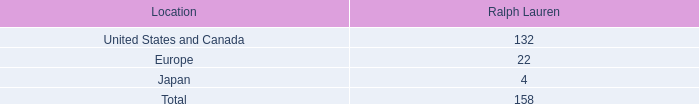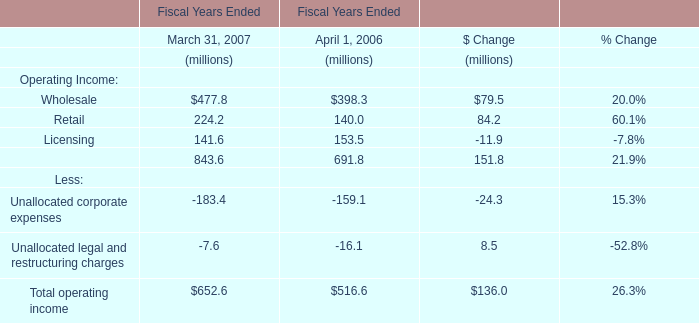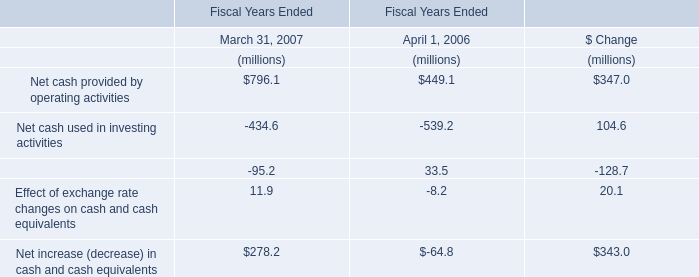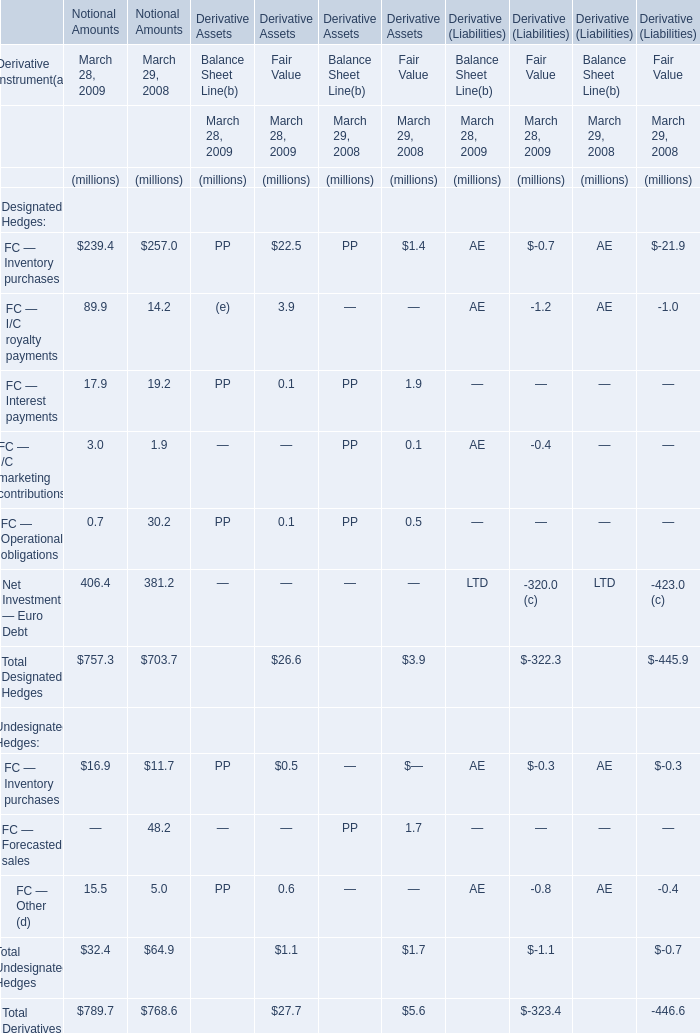What will Net Investment — Euro Debt for Notional Amounts be like in 2010 if it develops with the same increasing rate as current? (in million) 
Computations: (406.4 * (1 + ((406.4 - 381.2) / 381.2)))
Answer: 433.2659. 